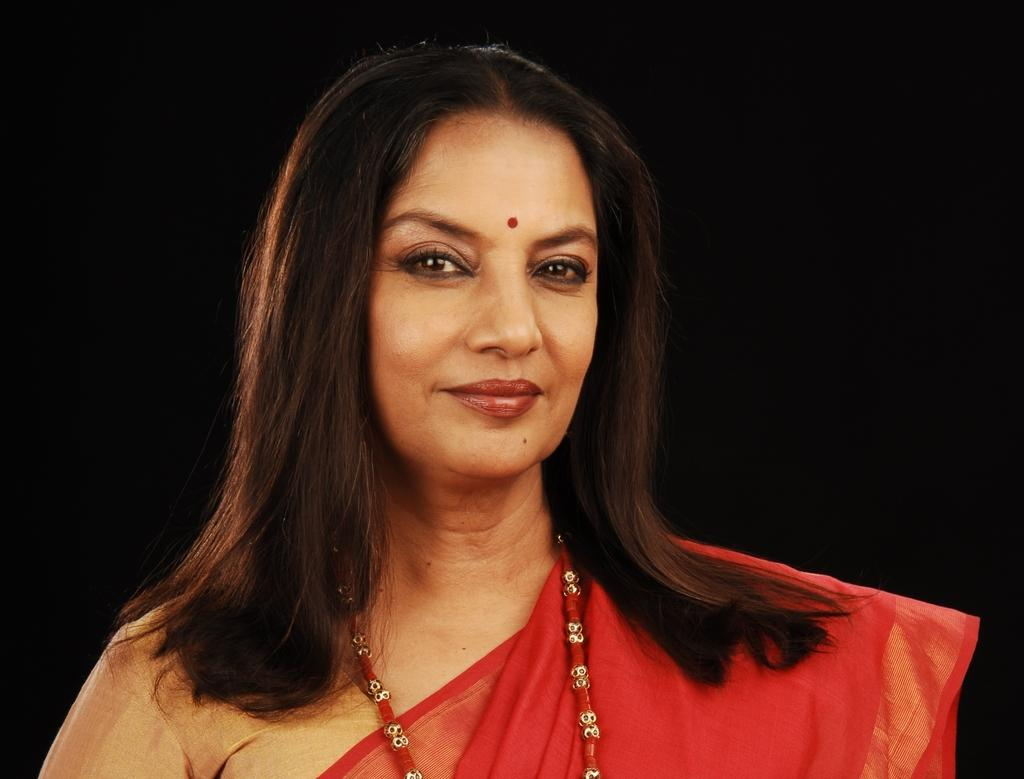Who is the person featured in the image? The image contains a picture of Shabana Azmi. How many coils can be seen in the picture of Shabana Azmi? There are no coils present in the picture of Shabana Azmi. How many ladybugs are visible on Shabana Azmi's shoulder in the image? There are no ladybugs visible on Shabana Azmi's shoulder in the image. 